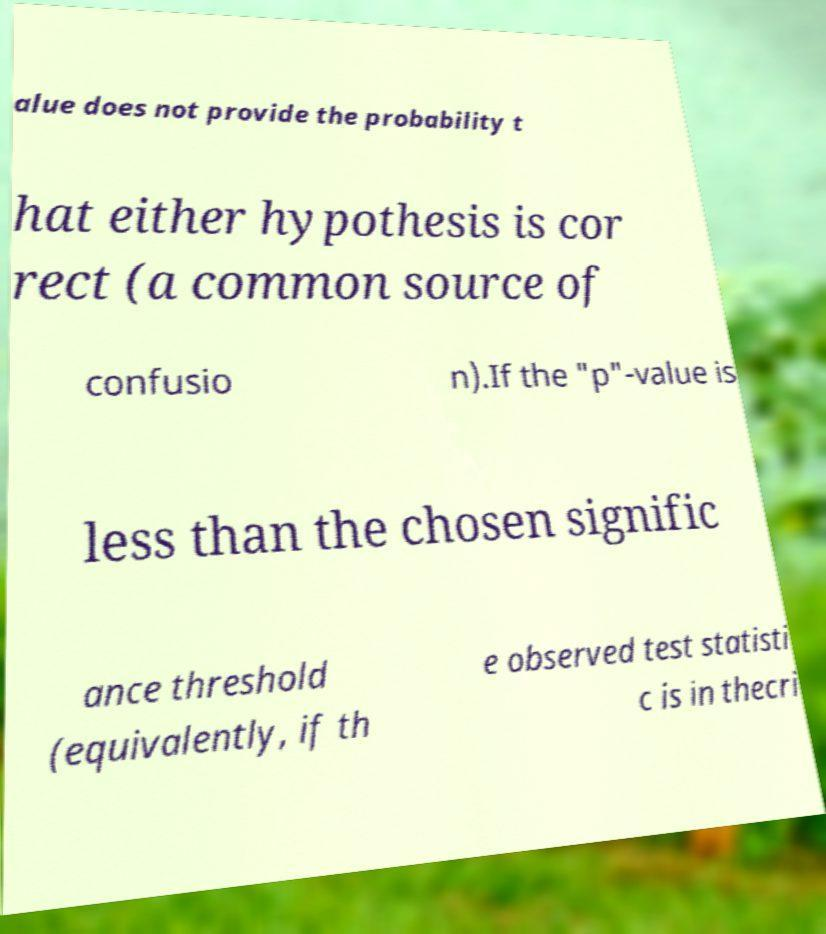For documentation purposes, I need the text within this image transcribed. Could you provide that? alue does not provide the probability t hat either hypothesis is cor rect (a common source of confusio n).If the "p"-value is less than the chosen signific ance threshold (equivalently, if th e observed test statisti c is in thecri 